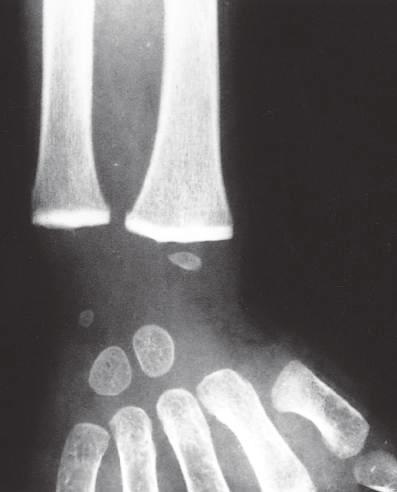have large, flat cells with small nuclei caused a marked increase in their radiodensity, so that they are as radiopaque as the cortical bone?
Answer the question using a single word or phrase. No 